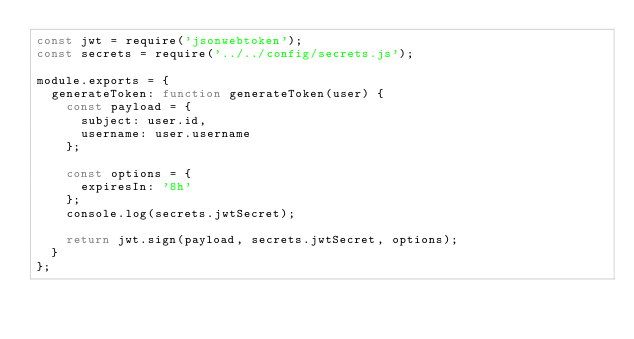<code> <loc_0><loc_0><loc_500><loc_500><_JavaScript_>const jwt = require('jsonwebtoken');
const secrets = require('../../config/secrets.js');

module.exports = {
	generateToken: function generateToken(user) {
		const payload = {
			subject: user.id,
			username: user.username
		};

		const options = {
			expiresIn: '8h'
		};
		console.log(secrets.jwtSecret);

		return jwt.sign(payload, secrets.jwtSecret, options);
	}
};
</code> 